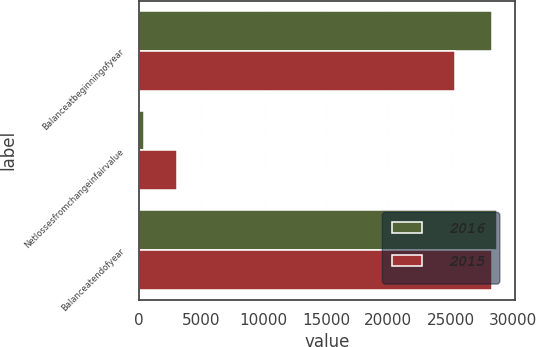<chart> <loc_0><loc_0><loc_500><loc_500><stacked_bar_chart><ecel><fcel>Balanceatbeginningofyear<fcel>Netlossesfromchangeinfairvalue<fcel>Balanceatendofyear<nl><fcel>2016<fcel>28360<fcel>410<fcel>28770<nl><fcel>2015<fcel>25340<fcel>3020<fcel>28360<nl></chart> 